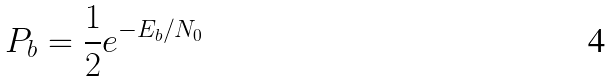Convert formula to latex. <formula><loc_0><loc_0><loc_500><loc_500>P _ { b } = \frac { 1 } { 2 } e ^ { - E _ { b } / N _ { 0 } }</formula> 